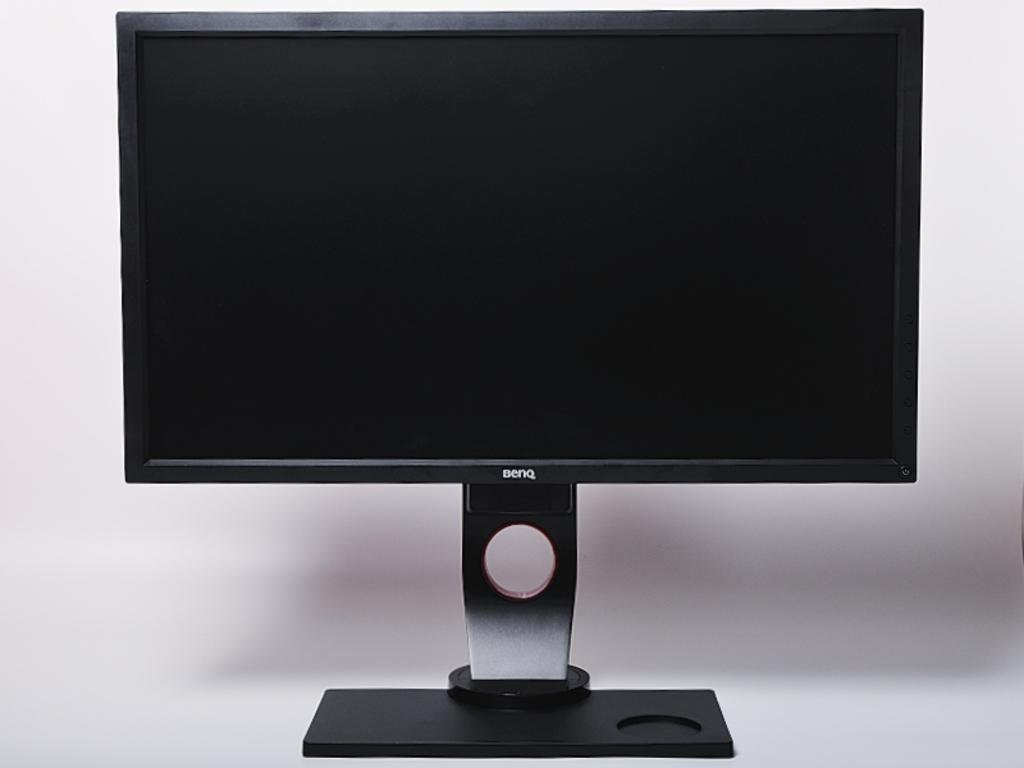Provide a one-sentence caption for the provided image. a Benq television that has a white background behind it. 